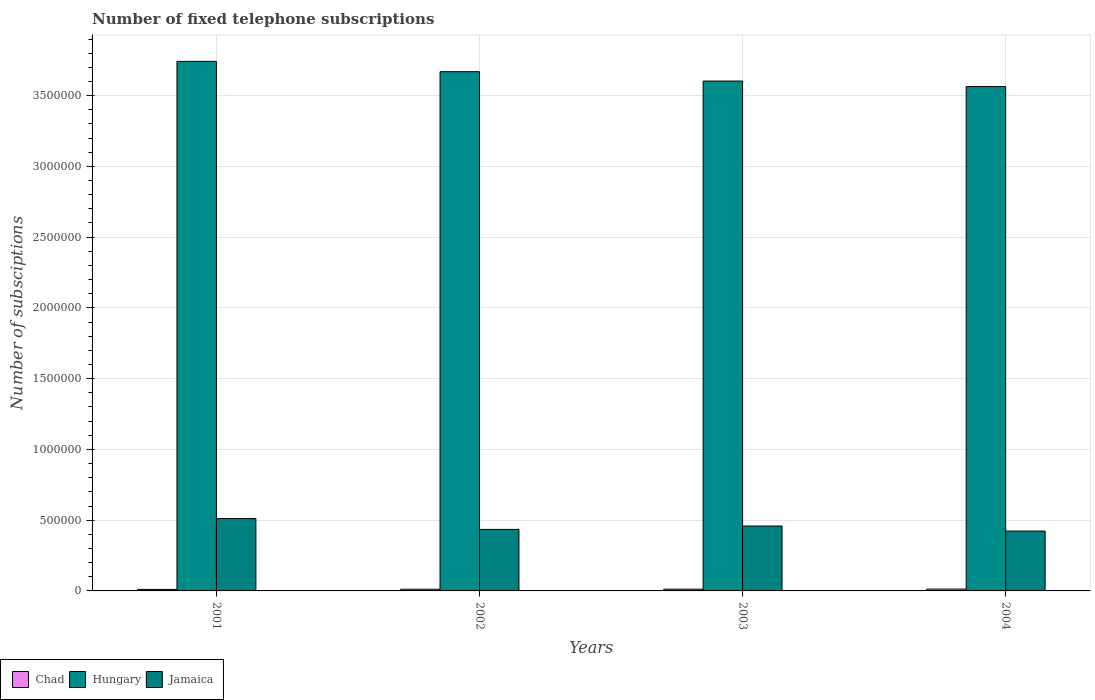How many different coloured bars are there?
Provide a succinct answer. 3. Are the number of bars per tick equal to the number of legend labels?
Offer a terse response. Yes. How many bars are there on the 4th tick from the left?
Your answer should be compact. 3. How many bars are there on the 3rd tick from the right?
Offer a terse response. 3. What is the number of fixed telephone subscriptions in Jamaica in 2004?
Your response must be concise. 4.23e+05. Across all years, what is the maximum number of fixed telephone subscriptions in Chad?
Your answer should be very brief. 1.30e+04. Across all years, what is the minimum number of fixed telephone subscriptions in Jamaica?
Your answer should be compact. 4.23e+05. In which year was the number of fixed telephone subscriptions in Hungary minimum?
Give a very brief answer. 2004. What is the total number of fixed telephone subscriptions in Chad in the graph?
Keep it short and to the point. 4.80e+04. What is the difference between the number of fixed telephone subscriptions in Hungary in 2001 and that in 2003?
Make the answer very short. 1.39e+05. What is the difference between the number of fixed telephone subscriptions in Jamaica in 2003 and the number of fixed telephone subscriptions in Hungary in 2004?
Ensure brevity in your answer.  -3.11e+06. What is the average number of fixed telephone subscriptions in Jamaica per year?
Make the answer very short. 4.57e+05. In the year 2004, what is the difference between the number of fixed telephone subscriptions in Chad and number of fixed telephone subscriptions in Jamaica?
Your response must be concise. -4.10e+05. In how many years, is the number of fixed telephone subscriptions in Chad greater than 2600000?
Your response must be concise. 0. What is the ratio of the number of fixed telephone subscriptions in Jamaica in 2001 to that in 2004?
Provide a succinct answer. 1.21. What is the difference between the highest and the second highest number of fixed telephone subscriptions in Jamaica?
Your response must be concise. 5.26e+04. What is the difference between the highest and the lowest number of fixed telephone subscriptions in Chad?
Provide a short and direct response. 2311. Is the sum of the number of fixed telephone subscriptions in Hungary in 2002 and 2003 greater than the maximum number of fixed telephone subscriptions in Jamaica across all years?
Your answer should be compact. Yes. What does the 3rd bar from the left in 2004 represents?
Provide a succinct answer. Jamaica. What does the 1st bar from the right in 2001 represents?
Give a very brief answer. Jamaica. Is it the case that in every year, the sum of the number of fixed telephone subscriptions in Jamaica and number of fixed telephone subscriptions in Hungary is greater than the number of fixed telephone subscriptions in Chad?
Your answer should be compact. Yes. How many bars are there?
Keep it short and to the point. 12. Are all the bars in the graph horizontal?
Ensure brevity in your answer.  No. How many years are there in the graph?
Your response must be concise. 4. Are the values on the major ticks of Y-axis written in scientific E-notation?
Your answer should be very brief. No. Does the graph contain grids?
Provide a succinct answer. Yes. Where does the legend appear in the graph?
Your answer should be compact. Bottom left. How are the legend labels stacked?
Make the answer very short. Horizontal. What is the title of the graph?
Ensure brevity in your answer.  Number of fixed telephone subscriptions. What is the label or title of the Y-axis?
Provide a succinct answer. Number of subsciptions. What is the Number of subsciptions in Chad in 2001?
Make the answer very short. 1.07e+04. What is the Number of subsciptions of Hungary in 2001?
Your answer should be very brief. 3.74e+06. What is the Number of subsciptions of Jamaica in 2001?
Offer a terse response. 5.11e+05. What is the Number of subsciptions in Chad in 2002?
Provide a succinct answer. 1.18e+04. What is the Number of subsciptions in Hungary in 2002?
Your answer should be very brief. 3.67e+06. What is the Number of subsciptions of Jamaica in 2002?
Your response must be concise. 4.35e+05. What is the Number of subsciptions of Chad in 2003?
Your answer should be very brief. 1.24e+04. What is the Number of subsciptions of Hungary in 2003?
Make the answer very short. 3.60e+06. What is the Number of subsciptions of Jamaica in 2003?
Ensure brevity in your answer.  4.59e+05. What is the Number of subsciptions in Chad in 2004?
Offer a terse response. 1.30e+04. What is the Number of subsciptions of Hungary in 2004?
Offer a terse response. 3.56e+06. What is the Number of subsciptions of Jamaica in 2004?
Offer a terse response. 4.23e+05. Across all years, what is the maximum Number of subsciptions of Chad?
Make the answer very short. 1.30e+04. Across all years, what is the maximum Number of subsciptions of Hungary?
Provide a succinct answer. 3.74e+06. Across all years, what is the maximum Number of subsciptions of Jamaica?
Your answer should be compact. 5.11e+05. Across all years, what is the minimum Number of subsciptions of Chad?
Keep it short and to the point. 1.07e+04. Across all years, what is the minimum Number of subsciptions in Hungary?
Offer a very short reply. 3.56e+06. Across all years, what is the minimum Number of subsciptions of Jamaica?
Your answer should be compact. 4.23e+05. What is the total Number of subsciptions of Chad in the graph?
Keep it short and to the point. 4.80e+04. What is the total Number of subsciptions of Hungary in the graph?
Your answer should be very brief. 1.46e+07. What is the total Number of subsciptions in Jamaica in the graph?
Provide a succinct answer. 1.83e+06. What is the difference between the Number of subsciptions in Chad in 2001 and that in 2002?
Your answer should be very brief. -1146. What is the difference between the Number of subsciptions in Hungary in 2001 and that in 2002?
Offer a terse response. 7.30e+04. What is the difference between the Number of subsciptions of Jamaica in 2001 and that in 2002?
Your response must be concise. 7.65e+04. What is the difference between the Number of subsciptions of Chad in 2001 and that in 2003?
Your answer should be compact. -1761. What is the difference between the Number of subsciptions in Hungary in 2001 and that in 2003?
Ensure brevity in your answer.  1.39e+05. What is the difference between the Number of subsciptions of Jamaica in 2001 and that in 2003?
Keep it short and to the point. 5.26e+04. What is the difference between the Number of subsciptions in Chad in 2001 and that in 2004?
Provide a short and direct response. -2311. What is the difference between the Number of subsciptions in Hungary in 2001 and that in 2004?
Keep it short and to the point. 1.78e+05. What is the difference between the Number of subsciptions in Jamaica in 2001 and that in 2004?
Ensure brevity in your answer.  8.83e+04. What is the difference between the Number of subsciptions of Chad in 2002 and that in 2003?
Provide a succinct answer. -615. What is the difference between the Number of subsciptions of Hungary in 2002 and that in 2003?
Give a very brief answer. 6.63e+04. What is the difference between the Number of subsciptions in Jamaica in 2002 and that in 2003?
Your answer should be compact. -2.39e+04. What is the difference between the Number of subsciptions in Chad in 2002 and that in 2004?
Provide a succinct answer. -1165. What is the difference between the Number of subsciptions of Hungary in 2002 and that in 2004?
Ensure brevity in your answer.  1.05e+05. What is the difference between the Number of subsciptions in Jamaica in 2002 and that in 2004?
Offer a terse response. 1.18e+04. What is the difference between the Number of subsciptions in Chad in 2003 and that in 2004?
Your answer should be compact. -550. What is the difference between the Number of subsciptions in Hungary in 2003 and that in 2004?
Your answer should be very brief. 3.89e+04. What is the difference between the Number of subsciptions of Jamaica in 2003 and that in 2004?
Your response must be concise. 3.57e+04. What is the difference between the Number of subsciptions in Chad in 2001 and the Number of subsciptions in Hungary in 2002?
Give a very brief answer. -3.66e+06. What is the difference between the Number of subsciptions in Chad in 2001 and the Number of subsciptions in Jamaica in 2002?
Your answer should be compact. -4.24e+05. What is the difference between the Number of subsciptions of Hungary in 2001 and the Number of subsciptions of Jamaica in 2002?
Ensure brevity in your answer.  3.31e+06. What is the difference between the Number of subsciptions in Chad in 2001 and the Number of subsciptions in Hungary in 2003?
Provide a short and direct response. -3.59e+06. What is the difference between the Number of subsciptions of Chad in 2001 and the Number of subsciptions of Jamaica in 2003?
Your response must be concise. -4.48e+05. What is the difference between the Number of subsciptions of Hungary in 2001 and the Number of subsciptions of Jamaica in 2003?
Provide a succinct answer. 3.28e+06. What is the difference between the Number of subsciptions of Chad in 2001 and the Number of subsciptions of Hungary in 2004?
Offer a very short reply. -3.55e+06. What is the difference between the Number of subsciptions in Chad in 2001 and the Number of subsciptions in Jamaica in 2004?
Keep it short and to the point. -4.12e+05. What is the difference between the Number of subsciptions of Hungary in 2001 and the Number of subsciptions of Jamaica in 2004?
Ensure brevity in your answer.  3.32e+06. What is the difference between the Number of subsciptions in Chad in 2002 and the Number of subsciptions in Hungary in 2003?
Make the answer very short. -3.59e+06. What is the difference between the Number of subsciptions in Chad in 2002 and the Number of subsciptions in Jamaica in 2003?
Provide a short and direct response. -4.47e+05. What is the difference between the Number of subsciptions in Hungary in 2002 and the Number of subsciptions in Jamaica in 2003?
Offer a terse response. 3.21e+06. What is the difference between the Number of subsciptions of Chad in 2002 and the Number of subsciptions of Hungary in 2004?
Ensure brevity in your answer.  -3.55e+06. What is the difference between the Number of subsciptions of Chad in 2002 and the Number of subsciptions of Jamaica in 2004?
Ensure brevity in your answer.  -4.11e+05. What is the difference between the Number of subsciptions of Hungary in 2002 and the Number of subsciptions of Jamaica in 2004?
Make the answer very short. 3.25e+06. What is the difference between the Number of subsciptions of Chad in 2003 and the Number of subsciptions of Hungary in 2004?
Give a very brief answer. -3.55e+06. What is the difference between the Number of subsciptions of Chad in 2003 and the Number of subsciptions of Jamaica in 2004?
Make the answer very short. -4.11e+05. What is the difference between the Number of subsciptions in Hungary in 2003 and the Number of subsciptions in Jamaica in 2004?
Your response must be concise. 3.18e+06. What is the average Number of subsciptions of Chad per year?
Provide a succinct answer. 1.20e+04. What is the average Number of subsciptions of Hungary per year?
Give a very brief answer. 3.64e+06. What is the average Number of subsciptions of Jamaica per year?
Make the answer very short. 4.57e+05. In the year 2001, what is the difference between the Number of subsciptions in Chad and Number of subsciptions in Hungary?
Provide a succinct answer. -3.73e+06. In the year 2001, what is the difference between the Number of subsciptions in Chad and Number of subsciptions in Jamaica?
Give a very brief answer. -5.01e+05. In the year 2001, what is the difference between the Number of subsciptions in Hungary and Number of subsciptions in Jamaica?
Offer a terse response. 3.23e+06. In the year 2002, what is the difference between the Number of subsciptions of Chad and Number of subsciptions of Hungary?
Make the answer very short. -3.66e+06. In the year 2002, what is the difference between the Number of subsciptions of Chad and Number of subsciptions of Jamaica?
Ensure brevity in your answer.  -4.23e+05. In the year 2002, what is the difference between the Number of subsciptions in Hungary and Number of subsciptions in Jamaica?
Your response must be concise. 3.23e+06. In the year 2003, what is the difference between the Number of subsciptions in Chad and Number of subsciptions in Hungary?
Keep it short and to the point. -3.59e+06. In the year 2003, what is the difference between the Number of subsciptions of Chad and Number of subsciptions of Jamaica?
Keep it short and to the point. -4.46e+05. In the year 2003, what is the difference between the Number of subsciptions of Hungary and Number of subsciptions of Jamaica?
Provide a short and direct response. 3.14e+06. In the year 2004, what is the difference between the Number of subsciptions in Chad and Number of subsciptions in Hungary?
Give a very brief answer. -3.55e+06. In the year 2004, what is the difference between the Number of subsciptions of Chad and Number of subsciptions of Jamaica?
Provide a short and direct response. -4.10e+05. In the year 2004, what is the difference between the Number of subsciptions in Hungary and Number of subsciptions in Jamaica?
Make the answer very short. 3.14e+06. What is the ratio of the Number of subsciptions of Chad in 2001 to that in 2002?
Your answer should be compact. 0.9. What is the ratio of the Number of subsciptions of Hungary in 2001 to that in 2002?
Keep it short and to the point. 1.02. What is the ratio of the Number of subsciptions of Jamaica in 2001 to that in 2002?
Make the answer very short. 1.18. What is the ratio of the Number of subsciptions of Chad in 2001 to that in 2003?
Make the answer very short. 0.86. What is the ratio of the Number of subsciptions in Hungary in 2001 to that in 2003?
Give a very brief answer. 1.04. What is the ratio of the Number of subsciptions in Jamaica in 2001 to that in 2003?
Provide a short and direct response. 1.11. What is the ratio of the Number of subsciptions of Chad in 2001 to that in 2004?
Keep it short and to the point. 0.82. What is the ratio of the Number of subsciptions of Jamaica in 2001 to that in 2004?
Offer a terse response. 1.21. What is the ratio of the Number of subsciptions of Chad in 2002 to that in 2003?
Offer a very short reply. 0.95. What is the ratio of the Number of subsciptions in Hungary in 2002 to that in 2003?
Provide a succinct answer. 1.02. What is the ratio of the Number of subsciptions in Jamaica in 2002 to that in 2003?
Your answer should be very brief. 0.95. What is the ratio of the Number of subsciptions of Chad in 2002 to that in 2004?
Offer a very short reply. 0.91. What is the ratio of the Number of subsciptions in Hungary in 2002 to that in 2004?
Your answer should be compact. 1.03. What is the ratio of the Number of subsciptions in Jamaica in 2002 to that in 2004?
Ensure brevity in your answer.  1.03. What is the ratio of the Number of subsciptions of Chad in 2003 to that in 2004?
Offer a terse response. 0.96. What is the ratio of the Number of subsciptions of Hungary in 2003 to that in 2004?
Your answer should be very brief. 1.01. What is the ratio of the Number of subsciptions of Jamaica in 2003 to that in 2004?
Give a very brief answer. 1.08. What is the difference between the highest and the second highest Number of subsciptions in Chad?
Your answer should be very brief. 550. What is the difference between the highest and the second highest Number of subsciptions of Hungary?
Ensure brevity in your answer.  7.30e+04. What is the difference between the highest and the second highest Number of subsciptions of Jamaica?
Your answer should be compact. 5.26e+04. What is the difference between the highest and the lowest Number of subsciptions of Chad?
Give a very brief answer. 2311. What is the difference between the highest and the lowest Number of subsciptions in Hungary?
Give a very brief answer. 1.78e+05. What is the difference between the highest and the lowest Number of subsciptions of Jamaica?
Your response must be concise. 8.83e+04. 